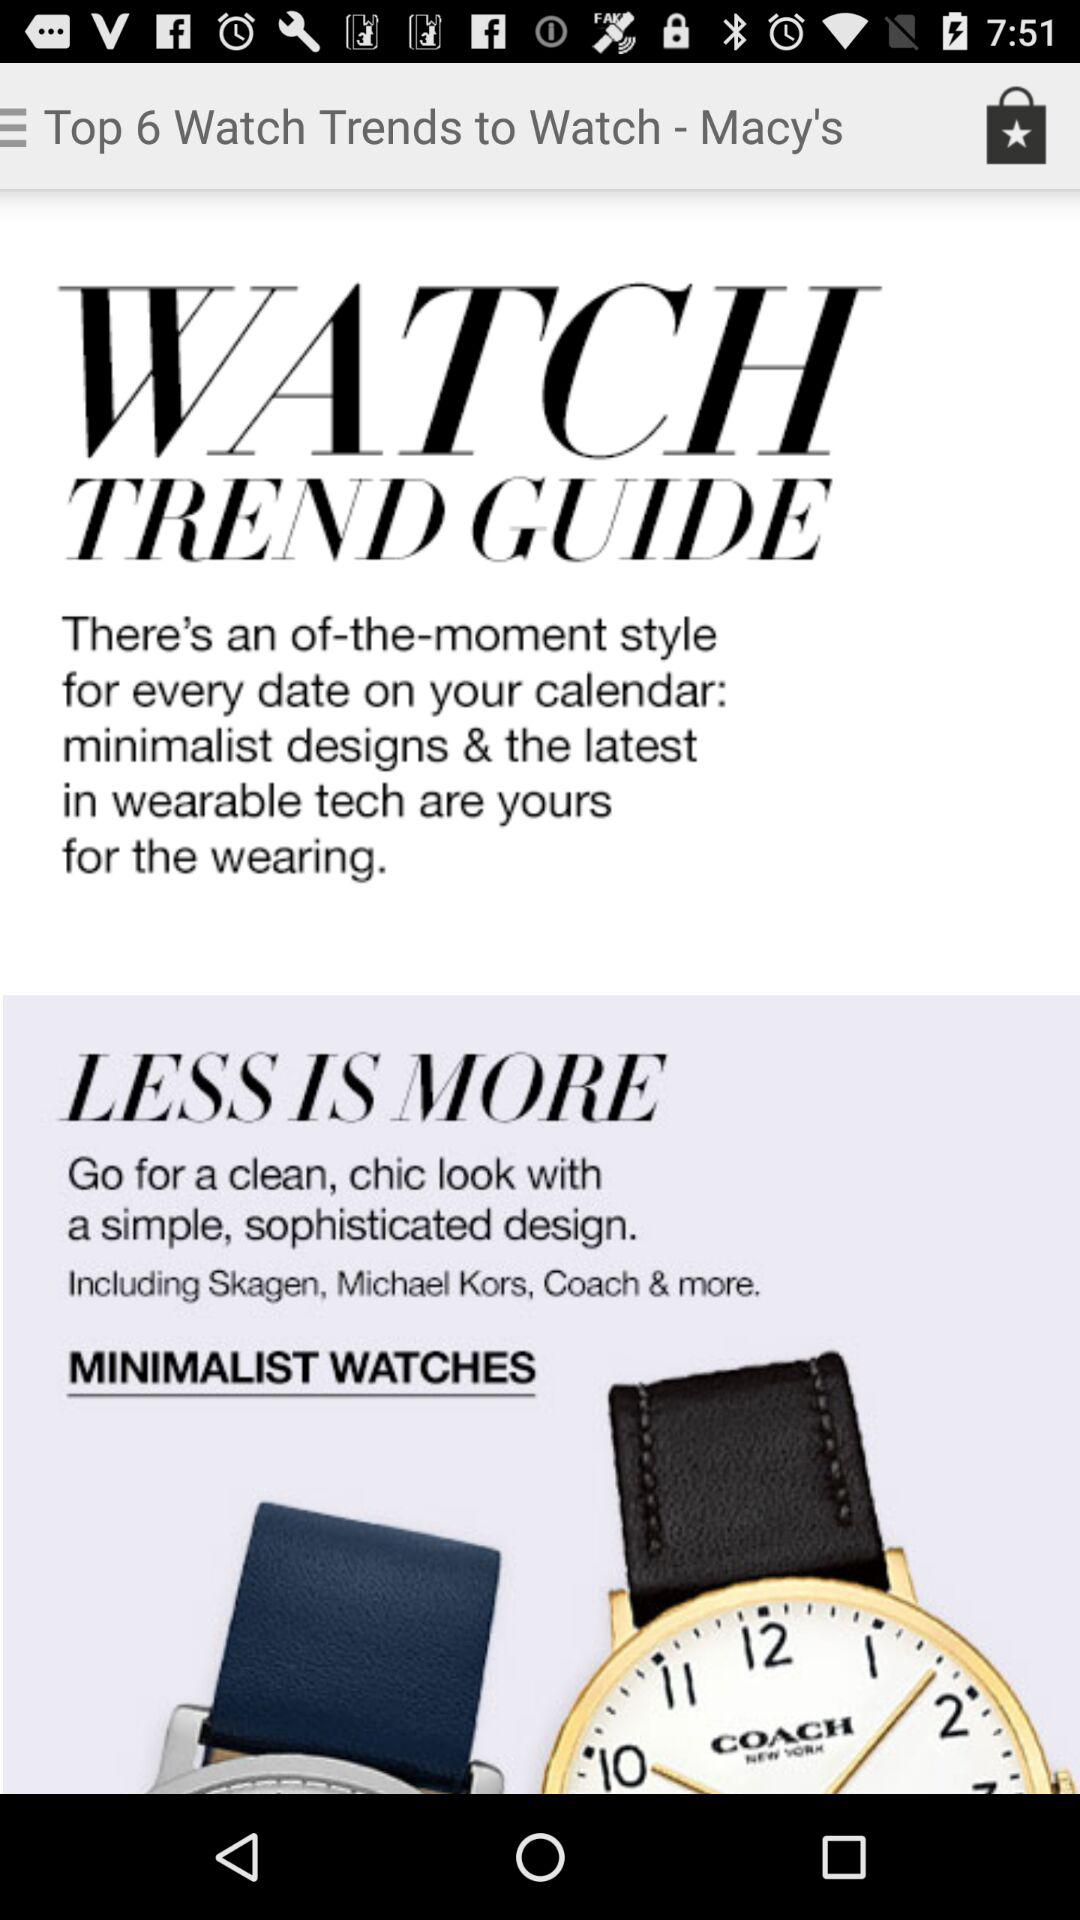What are the different brands of watches available? The different brands of watches available are "Skagen", "Michael Kors", "Coach" & more. 